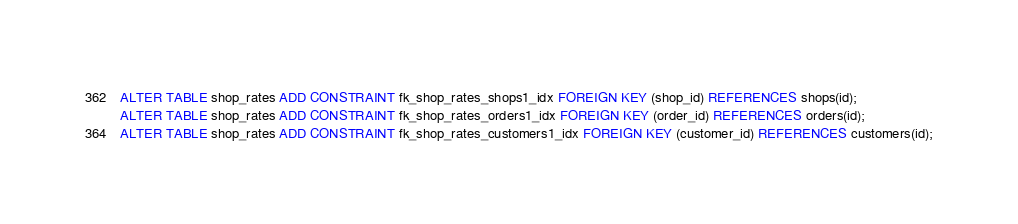Convert code to text. <code><loc_0><loc_0><loc_500><loc_500><_SQL_>ALTER TABLE shop_rates ADD CONSTRAINT fk_shop_rates_shops1_idx FOREIGN KEY (shop_id) REFERENCES shops(id);
ALTER TABLE shop_rates ADD CONSTRAINT fk_shop_rates_orders1_idx FOREIGN KEY (order_id) REFERENCES orders(id);
ALTER TABLE shop_rates ADD CONSTRAINT fk_shop_rates_customers1_idx FOREIGN KEY (customer_id) REFERENCES customers(id);</code> 